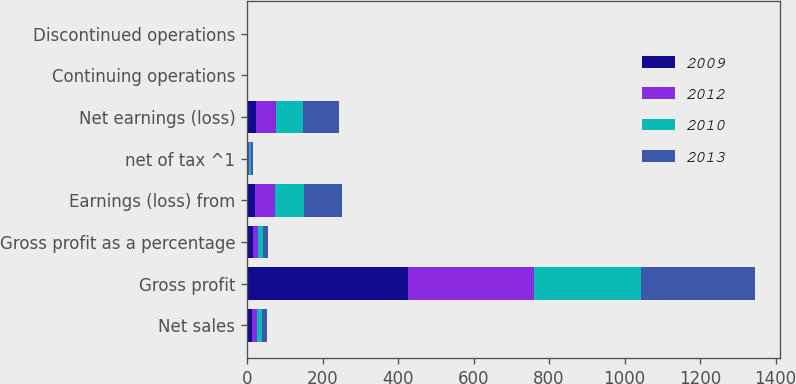Convert chart. <chart><loc_0><loc_0><loc_500><loc_500><stacked_bar_chart><ecel><fcel>Net sales<fcel>Gross profit<fcel>Gross profit as a percentage<fcel>Earnings (loss) from<fcel>net of tax ^1<fcel>Net earnings (loss)<fcel>Continuing operations<fcel>Discontinued operations<nl><fcel>2009<fcel>13.2<fcel>426.9<fcel>16.2<fcel>20.8<fcel>3.6<fcel>24.4<fcel>0.16<fcel>0.03<nl><fcel>2012<fcel>13.2<fcel>334<fcel>13.9<fcel>53.9<fcel>1.3<fcel>52.6<fcel>0.42<fcel>0.01<nl><fcel>2010<fcel>13.2<fcel>283.9<fcel>11.8<fcel>75.3<fcel>4.5<fcel>70.8<fcel>0.58<fcel>0.03<nl><fcel>2013<fcel>13.2<fcel>300.7<fcel>12.5<fcel>102.5<fcel>6<fcel>96.5<fcel>0.8<fcel>0.05<nl></chart> 